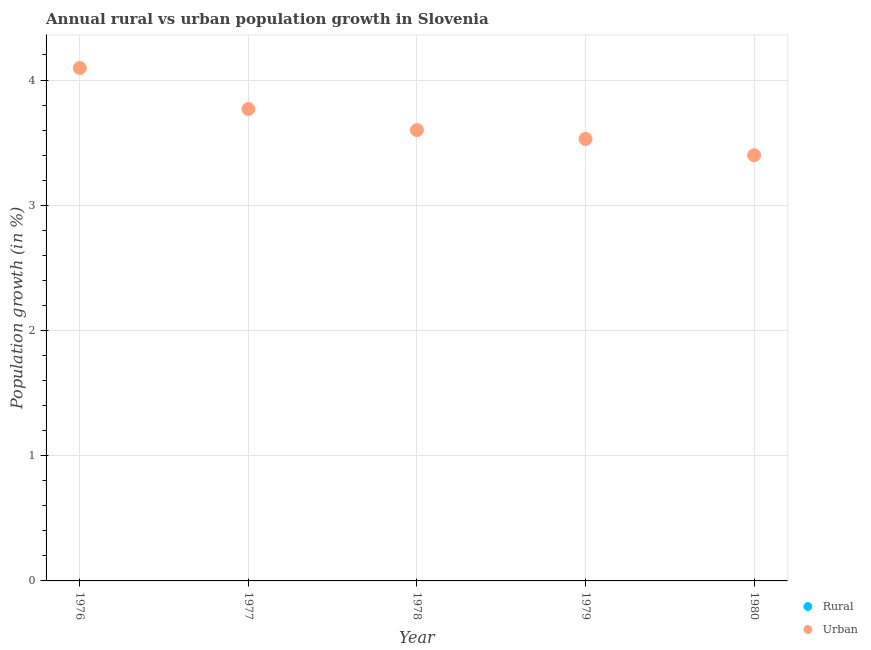Across all years, what is the maximum urban population growth?
Provide a succinct answer. 4.1. Across all years, what is the minimum urban population growth?
Provide a succinct answer. 3.4. In which year was the urban population growth maximum?
Your answer should be very brief. 1976. What is the difference between the urban population growth in 1976 and that in 1980?
Your answer should be very brief. 0.7. What is the difference between the urban population growth in 1979 and the rural population growth in 1978?
Keep it short and to the point. 3.53. What is the average rural population growth per year?
Offer a very short reply. 0. In how many years, is the urban population growth greater than 0.8 %?
Offer a very short reply. 5. What is the ratio of the urban population growth in 1977 to that in 1980?
Provide a short and direct response. 1.11. Is the urban population growth in 1977 less than that in 1979?
Make the answer very short. No. What is the difference between the highest and the second highest urban population growth?
Your answer should be compact. 0.33. What is the difference between the highest and the lowest urban population growth?
Ensure brevity in your answer.  0.7. Does the urban population growth monotonically increase over the years?
Ensure brevity in your answer.  No. Is the urban population growth strictly greater than the rural population growth over the years?
Provide a short and direct response. Yes. Is the rural population growth strictly less than the urban population growth over the years?
Offer a very short reply. Yes. How are the legend labels stacked?
Give a very brief answer. Vertical. What is the title of the graph?
Ensure brevity in your answer.  Annual rural vs urban population growth in Slovenia. Does "By country of origin" appear as one of the legend labels in the graph?
Make the answer very short. No. What is the label or title of the X-axis?
Your answer should be very brief. Year. What is the label or title of the Y-axis?
Provide a succinct answer. Population growth (in %). What is the Population growth (in %) in Urban  in 1976?
Ensure brevity in your answer.  4.1. What is the Population growth (in %) of Urban  in 1977?
Provide a short and direct response. 3.77. What is the Population growth (in %) of Rural in 1978?
Make the answer very short. 0. What is the Population growth (in %) of Urban  in 1978?
Provide a short and direct response. 3.6. What is the Population growth (in %) in Urban  in 1979?
Your answer should be compact. 3.53. What is the Population growth (in %) of Rural in 1980?
Offer a terse response. 0. What is the Population growth (in %) of Urban  in 1980?
Ensure brevity in your answer.  3.4. Across all years, what is the maximum Population growth (in %) of Urban ?
Keep it short and to the point. 4.1. Across all years, what is the minimum Population growth (in %) of Urban ?
Your answer should be compact. 3.4. What is the total Population growth (in %) in Rural in the graph?
Provide a succinct answer. 0. What is the total Population growth (in %) of Urban  in the graph?
Your response must be concise. 18.39. What is the difference between the Population growth (in %) of Urban  in 1976 and that in 1977?
Make the answer very short. 0.33. What is the difference between the Population growth (in %) of Urban  in 1976 and that in 1978?
Make the answer very short. 0.5. What is the difference between the Population growth (in %) of Urban  in 1976 and that in 1979?
Ensure brevity in your answer.  0.57. What is the difference between the Population growth (in %) in Urban  in 1976 and that in 1980?
Make the answer very short. 0.7. What is the difference between the Population growth (in %) in Urban  in 1977 and that in 1978?
Ensure brevity in your answer.  0.17. What is the difference between the Population growth (in %) in Urban  in 1977 and that in 1979?
Make the answer very short. 0.24. What is the difference between the Population growth (in %) in Urban  in 1977 and that in 1980?
Offer a very short reply. 0.37. What is the difference between the Population growth (in %) in Urban  in 1978 and that in 1979?
Offer a very short reply. 0.07. What is the difference between the Population growth (in %) in Urban  in 1978 and that in 1980?
Ensure brevity in your answer.  0.2. What is the difference between the Population growth (in %) in Urban  in 1979 and that in 1980?
Make the answer very short. 0.13. What is the average Population growth (in %) of Rural per year?
Keep it short and to the point. 0. What is the average Population growth (in %) of Urban  per year?
Keep it short and to the point. 3.68. What is the ratio of the Population growth (in %) of Urban  in 1976 to that in 1977?
Offer a terse response. 1.09. What is the ratio of the Population growth (in %) of Urban  in 1976 to that in 1978?
Provide a short and direct response. 1.14. What is the ratio of the Population growth (in %) of Urban  in 1976 to that in 1979?
Offer a terse response. 1.16. What is the ratio of the Population growth (in %) of Urban  in 1976 to that in 1980?
Your answer should be compact. 1.21. What is the ratio of the Population growth (in %) of Urban  in 1977 to that in 1978?
Make the answer very short. 1.05. What is the ratio of the Population growth (in %) of Urban  in 1977 to that in 1979?
Offer a terse response. 1.07. What is the ratio of the Population growth (in %) of Urban  in 1977 to that in 1980?
Make the answer very short. 1.11. What is the ratio of the Population growth (in %) of Urban  in 1978 to that in 1979?
Give a very brief answer. 1.02. What is the ratio of the Population growth (in %) of Urban  in 1978 to that in 1980?
Offer a very short reply. 1.06. What is the ratio of the Population growth (in %) in Urban  in 1979 to that in 1980?
Ensure brevity in your answer.  1.04. What is the difference between the highest and the second highest Population growth (in %) of Urban ?
Ensure brevity in your answer.  0.33. What is the difference between the highest and the lowest Population growth (in %) in Urban ?
Your response must be concise. 0.7. 